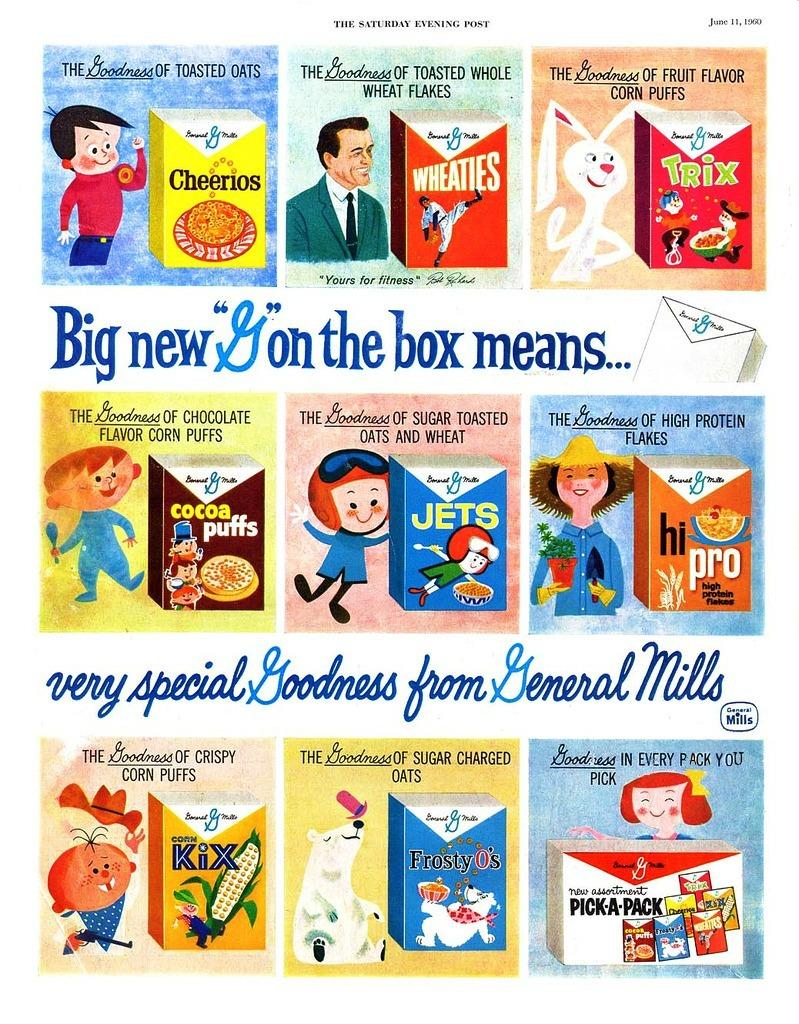What is featured on the poster in the image? There is a poster in the image that contains cartons and boxes. What else can be found on the poster besides the cartons and boxes? There is text on the poster. What type of seed is being planted by the governor in the image? There is no governor or seed present in the image. How many cars are visible in the image? There are no cars present in the image. 